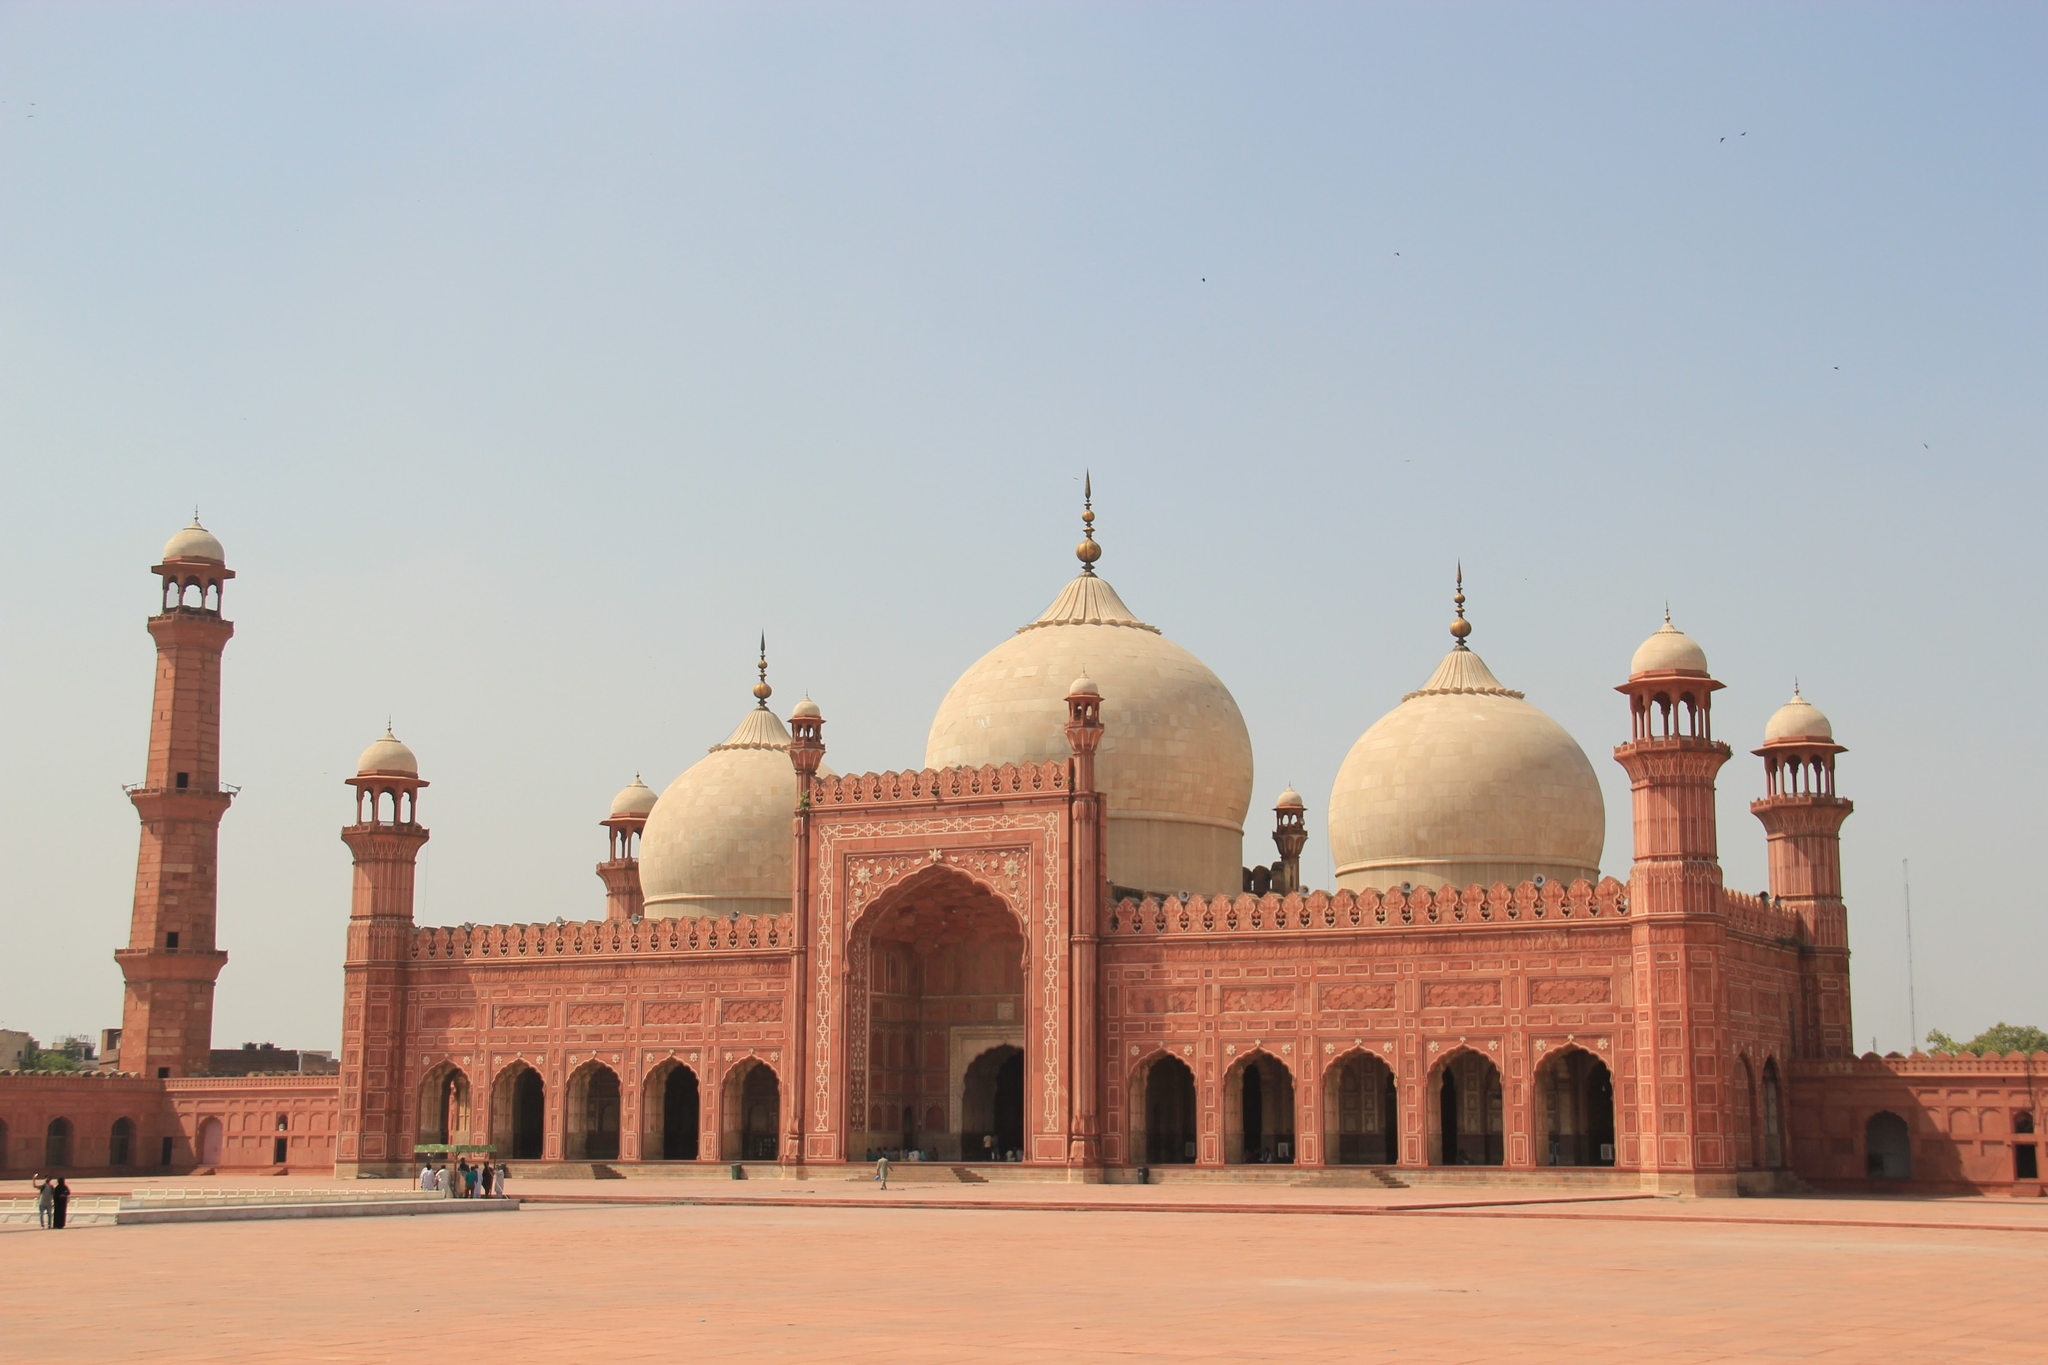Can you tell me more about the historical significance of the Badshahi Mosque? The Badshahi Mosque holds a profound place in history as one of the largest mosques in the world at the time of its completion in 1673 under the reign of Mughal Emperor Aurangzeb. It symbolizes the Islamic cultural heritage of Pakistan and represents the religious zeal and architectural expertise of the Mughal era. The mosque has been a central stage for numerous historical events, serving as a military stronghold during the Sikh Empire and later, under British rule, as a secular institution before being restored to a religious site post-independence. What are some architectural features that are unique to this mosque? Unique architectural features of the Badshahi Mosque include its vast courtyard that can hold tens of thousands of worshippers, the intricate frescoes inside its main prayer hall, and the use of red sandstone offset with marble inlay. Its eight-sided, bulbous domes are a typical element of Mughal architecture, optimized for echo within the main hall to enhance the acoustic effects during prayers. Additionally, the Mosque’s minarets are among the tallest in the world, designed to project the call to prayer across a considerable distance. 